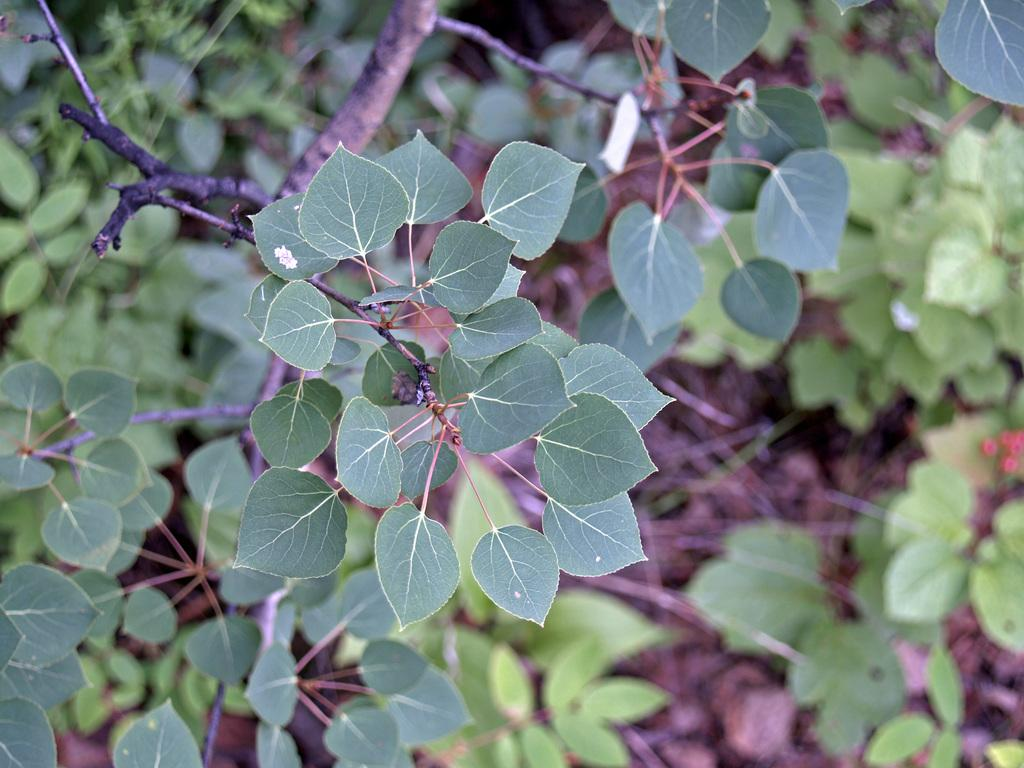What type of vegetation can be seen in the image? There are green color leaves in the image. What else is present in the image besides the leaves? There are sticks and stems in the image. Can you describe the quality of the image? The image is slightly blurry. What historical event is depicted in the image? There is no historical event depicted in the image; it features green leaves, sticks, and stems. What sense is being stimulated by the image? The image does not stimulate any specific sense; it is a visual representation of leaves, sticks, and stems. 